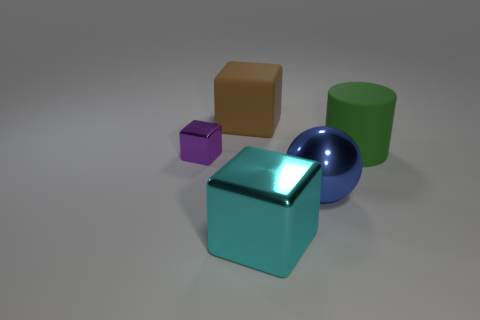Are there any large green things on the left side of the shiny block that is right of the shiny object behind the big blue object? no 